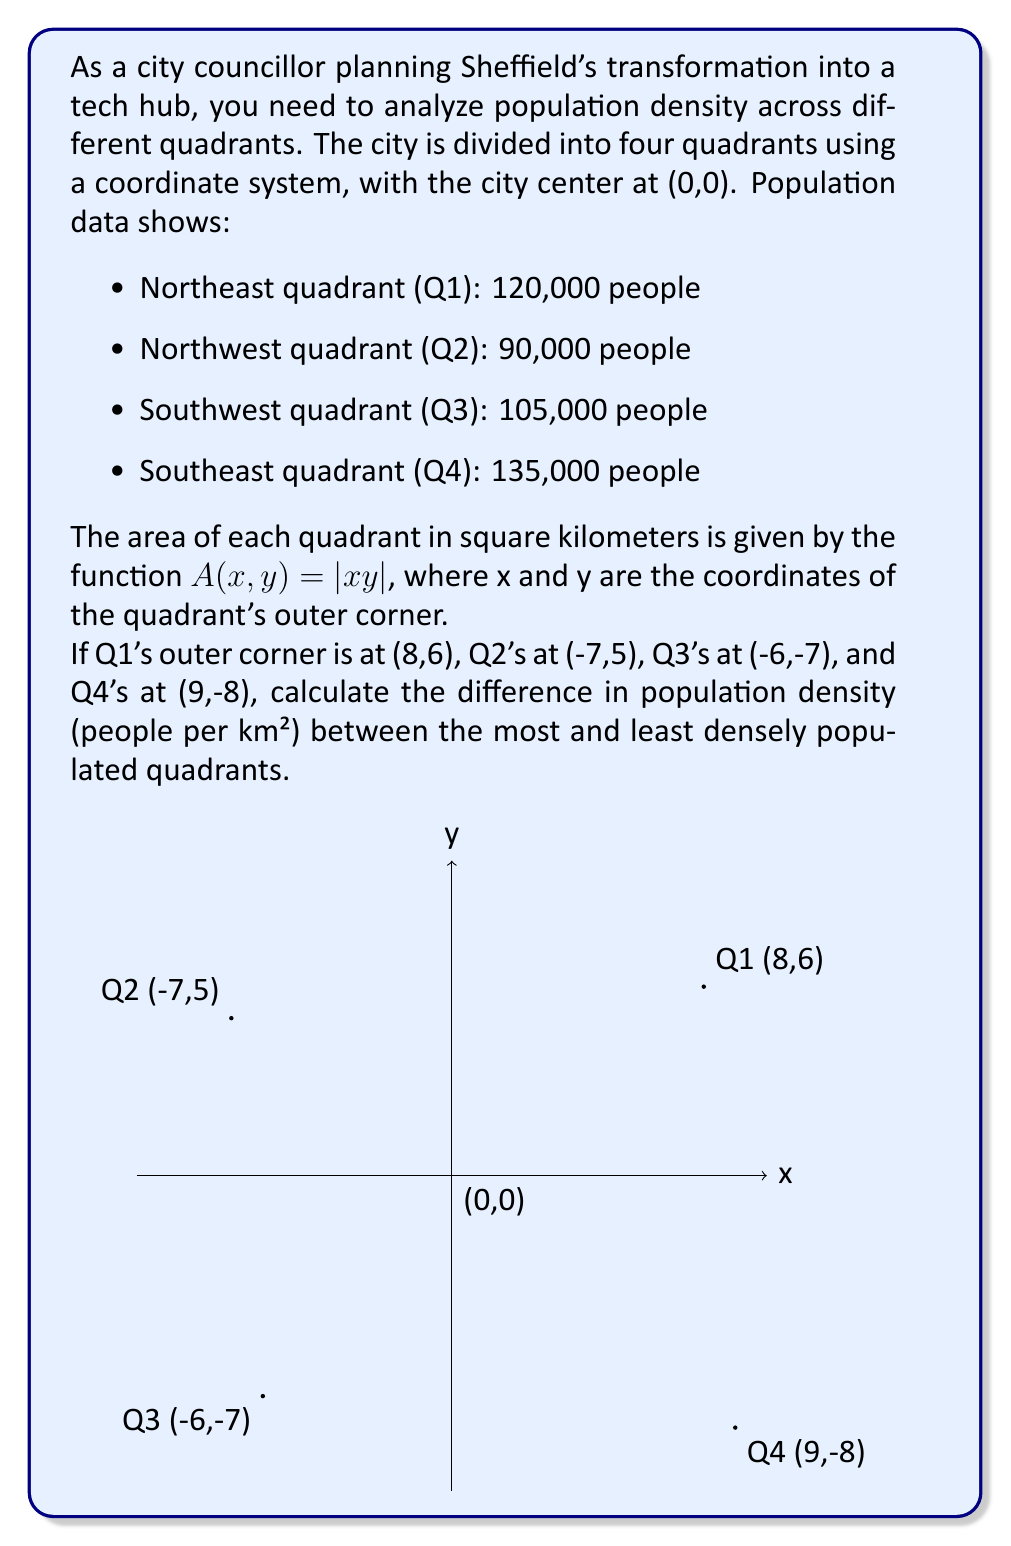Help me with this question. Let's approach this step-by-step:

1) First, calculate the area of each quadrant using $A(x,y) = |xy|$:

   Q1: $A(8,6) = |8 \times 6| = 48$ km²
   Q2: $A(-7,5) = |-7 \times 5| = 35$ km²
   Q3: $A(-6,-7) = |-6 \times -7| = 42$ km²
   Q4: $A(9,-8) = |9 \times -8| = 72$ km²

2) Now, calculate the population density for each quadrant using $\text{Density} = \frac{\text{Population}}{\text{Area}}$:

   Q1: $\frac{120,000}{48} = 2,500$ people/km²
   Q2: $\frac{90,000}{35} \approx 2,571.43$ people/km²
   Q3: $\frac{105,000}{42} = 2,500$ people/km²
   Q4: $\frac{135,000}{72} = 1,875$ people/km²

3) Identify the most and least densely populated quadrants:
   Most dense: Q2 with 2,571.43 people/km²
   Least dense: Q4 with 1,875 people/km²

4) Calculate the difference in density:
   $2,571.43 - 1,875 = 696.43$ people/km²

Therefore, the difference in population density between the most and least densely populated quadrants is approximately 696.43 people/km².
Answer: 696.43 people/km² 